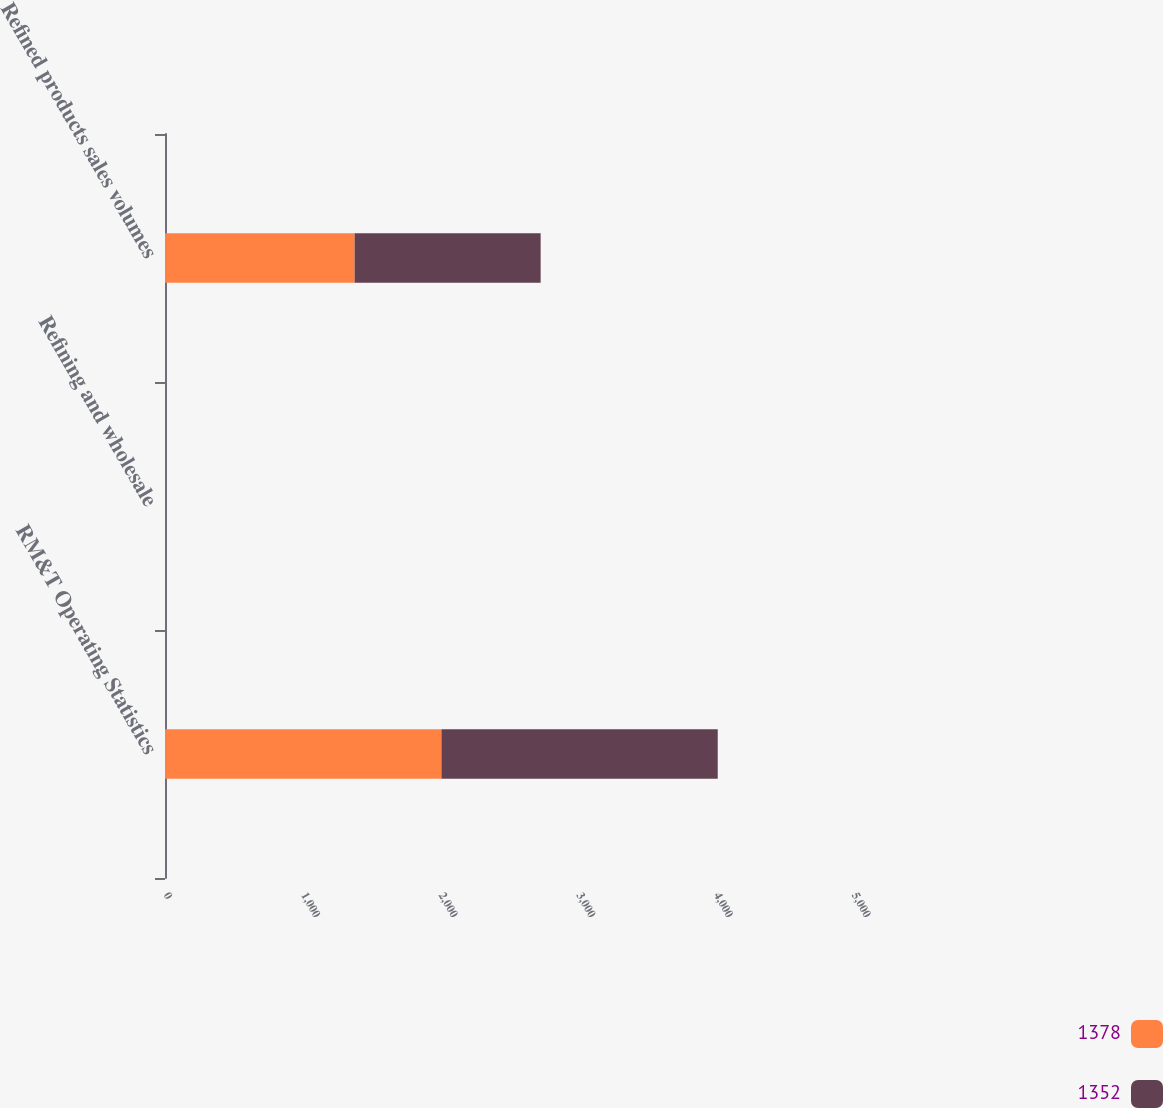Convert chart. <chart><loc_0><loc_0><loc_500><loc_500><stacked_bar_chart><ecel><fcel>RM&T Operating Statistics<fcel>Refining and wholesale<fcel>Refined products sales volumes<nl><fcel>1378<fcel>2009<fcel>0.06<fcel>1378<nl><fcel>1352<fcel>2008<fcel>0.12<fcel>1352<nl></chart> 